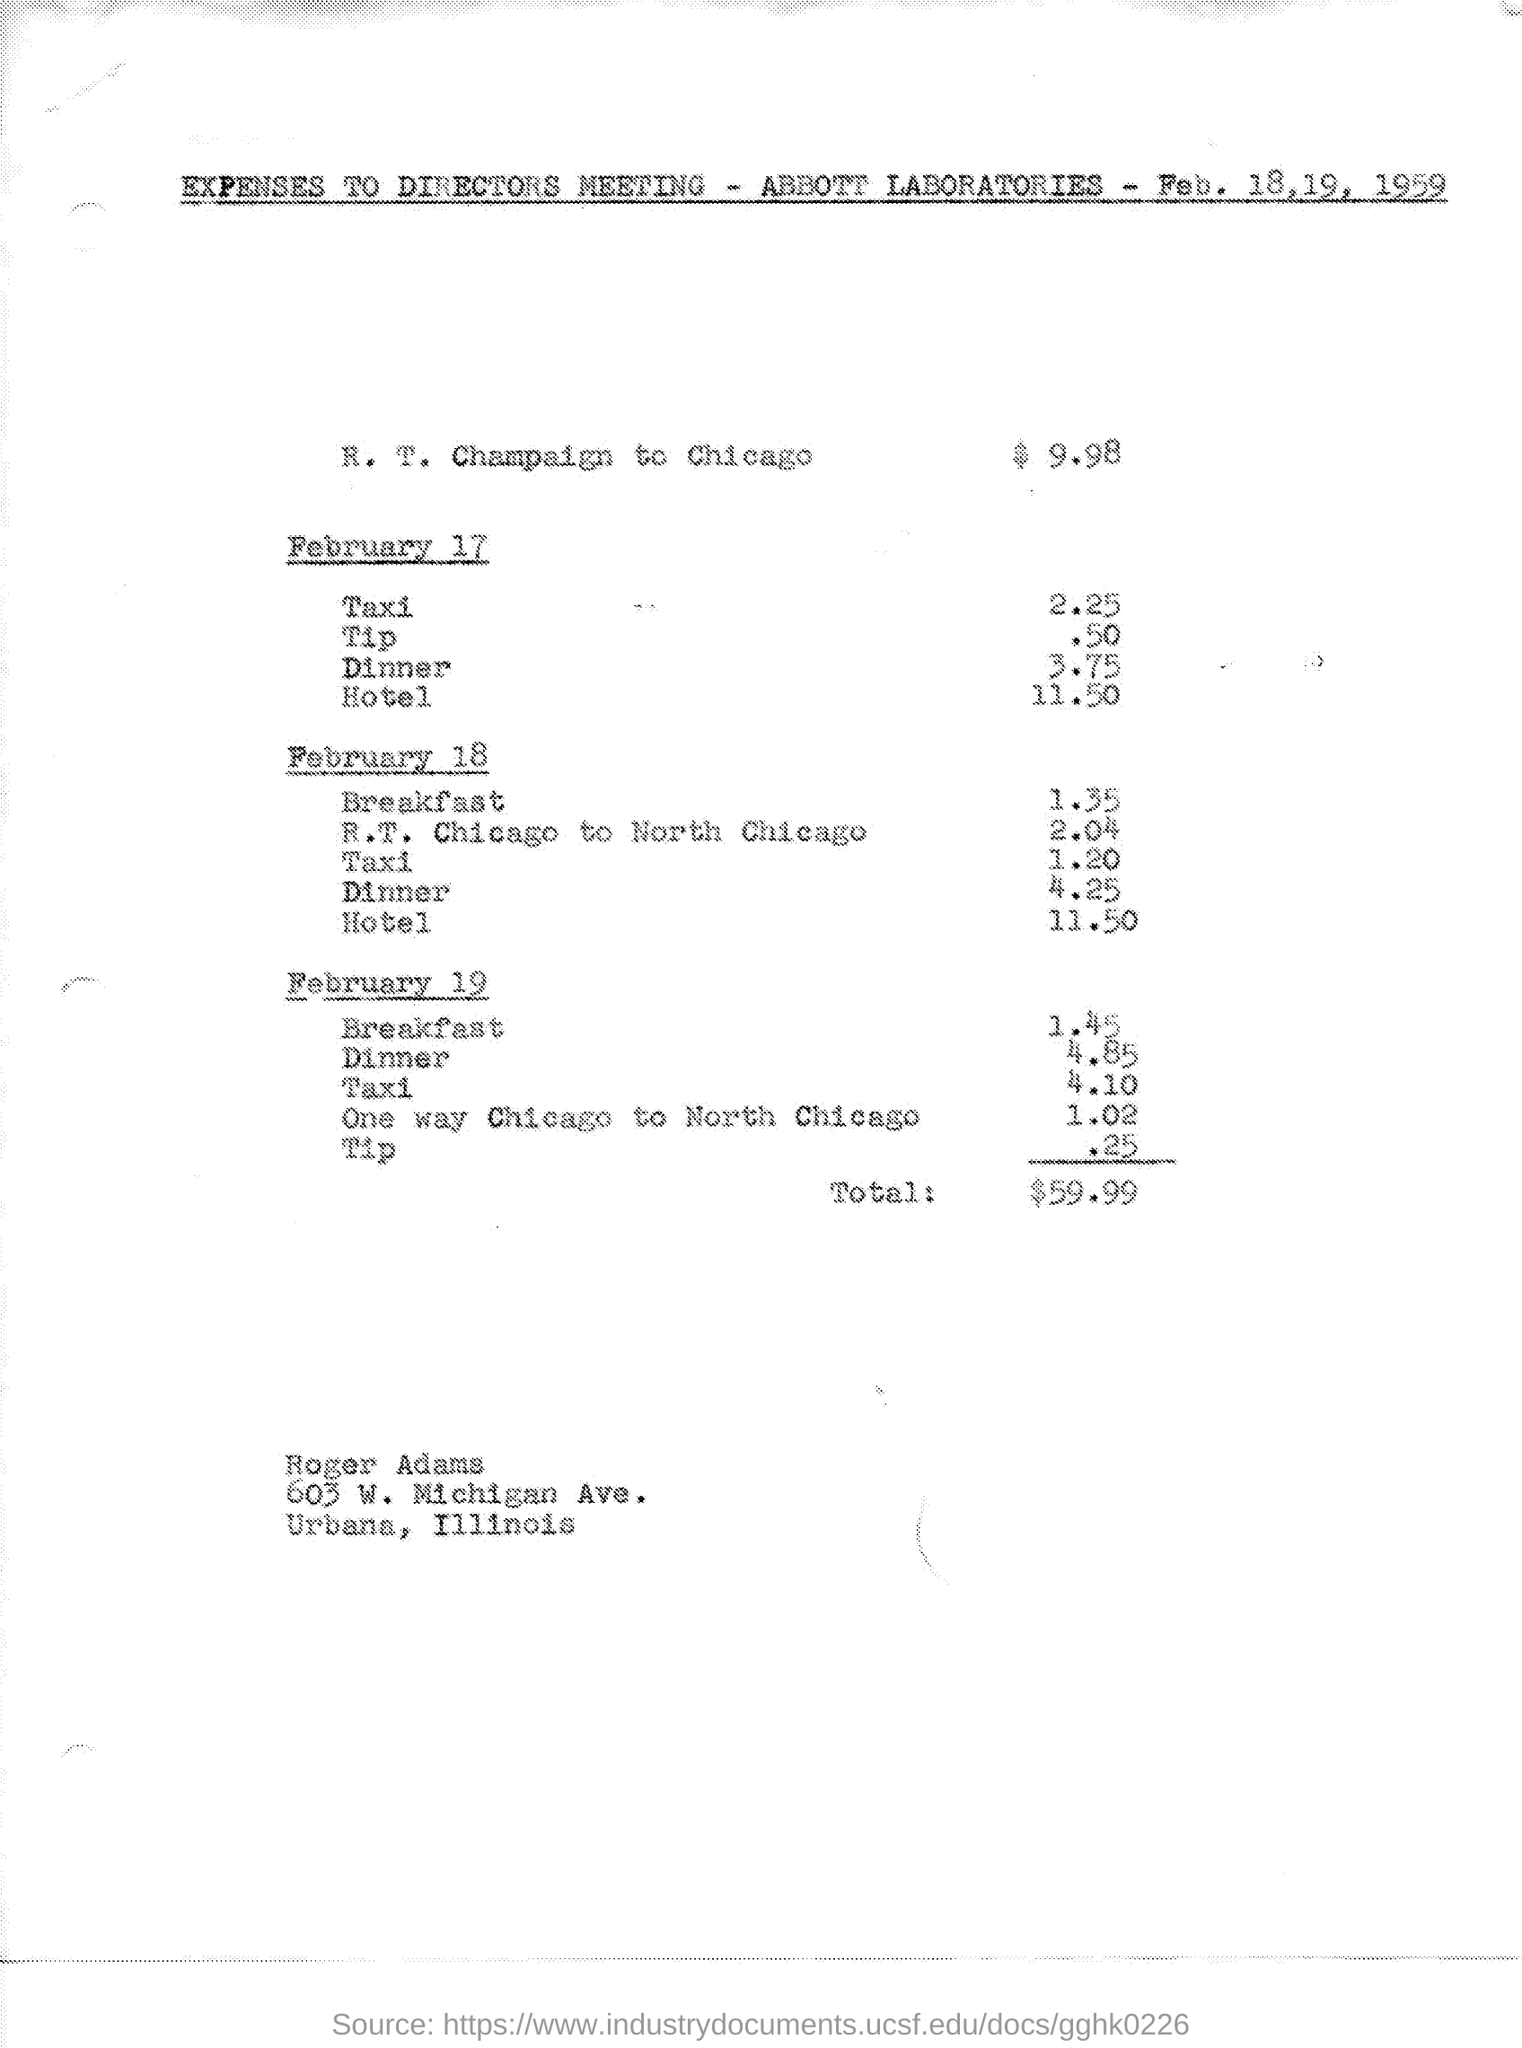Which laboratory is mentioned?
Provide a short and direct response. Abbott laboratories. What is the total amount?
Your answer should be compact. $ 59.99. What is the amount of R. T. Champaign to Chicago?
Ensure brevity in your answer.  $ 9.98. Whose name is mentioned at the bottom of the page?
Offer a terse response. Roger Adams. 